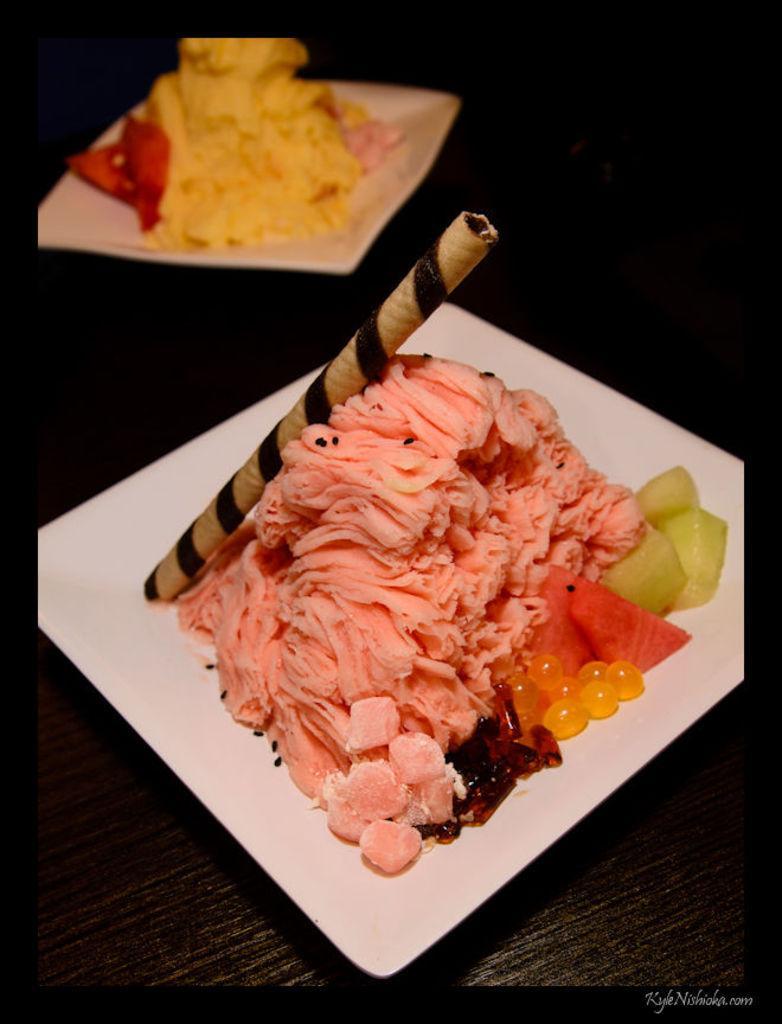Could you give a brief overview of what you see in this image? In this picture we can see food in the plates. 